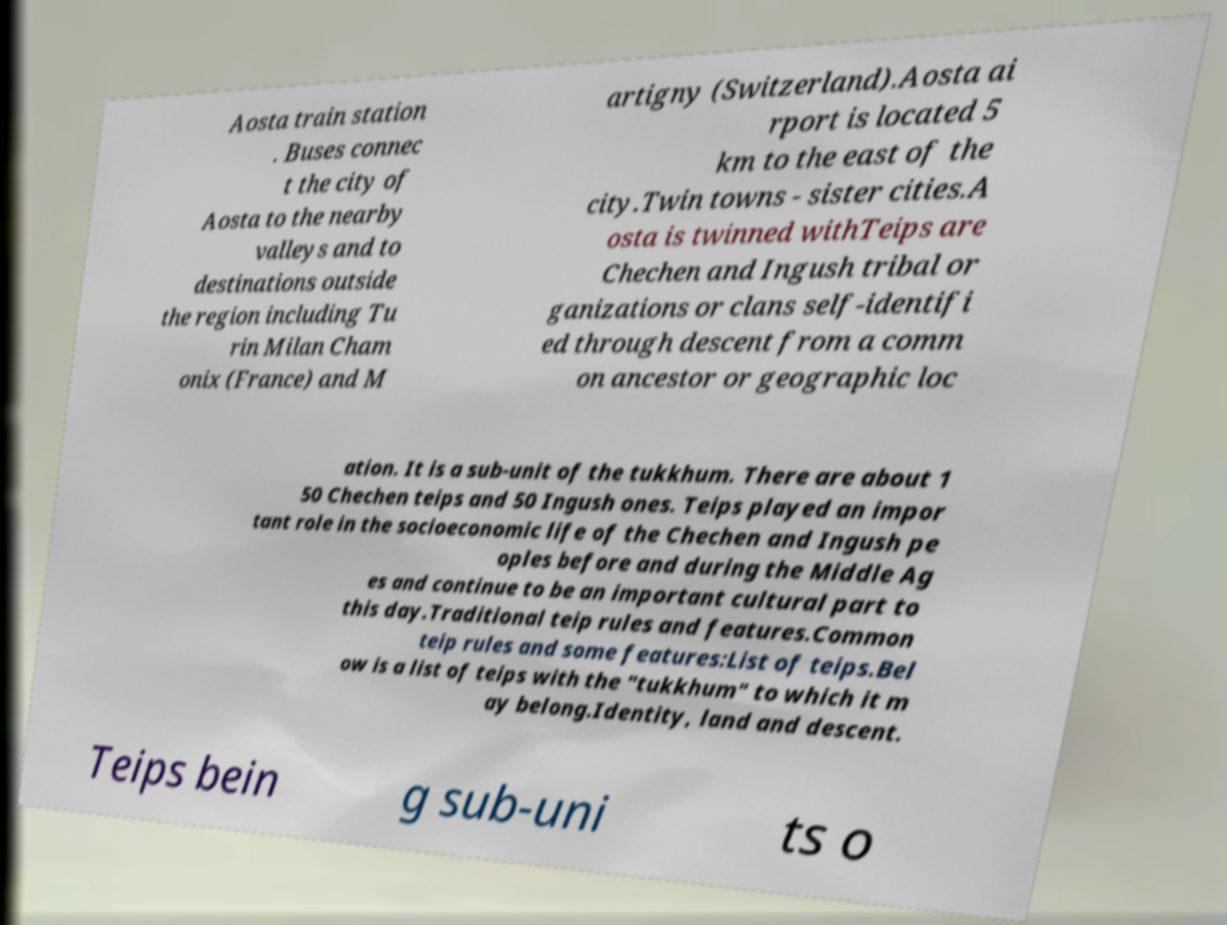Can you read and provide the text displayed in the image?This photo seems to have some interesting text. Can you extract and type it out for me? Aosta train station . Buses connec t the city of Aosta to the nearby valleys and to destinations outside the region including Tu rin Milan Cham onix (France) and M artigny (Switzerland).Aosta ai rport is located 5 km to the east of the city.Twin towns - sister cities.A osta is twinned withTeips are Chechen and Ingush tribal or ganizations or clans self-identifi ed through descent from a comm on ancestor or geographic loc ation. It is a sub-unit of the tukkhum. There are about 1 50 Chechen teips and 50 Ingush ones. Teips played an impor tant role in the socioeconomic life of the Chechen and Ingush pe oples before and during the Middle Ag es and continue to be an important cultural part to this day.Traditional teip rules and features.Common teip rules and some features:List of teips.Bel ow is a list of teips with the "tukkhum" to which it m ay belong.Identity, land and descent. Teips bein g sub-uni ts o 